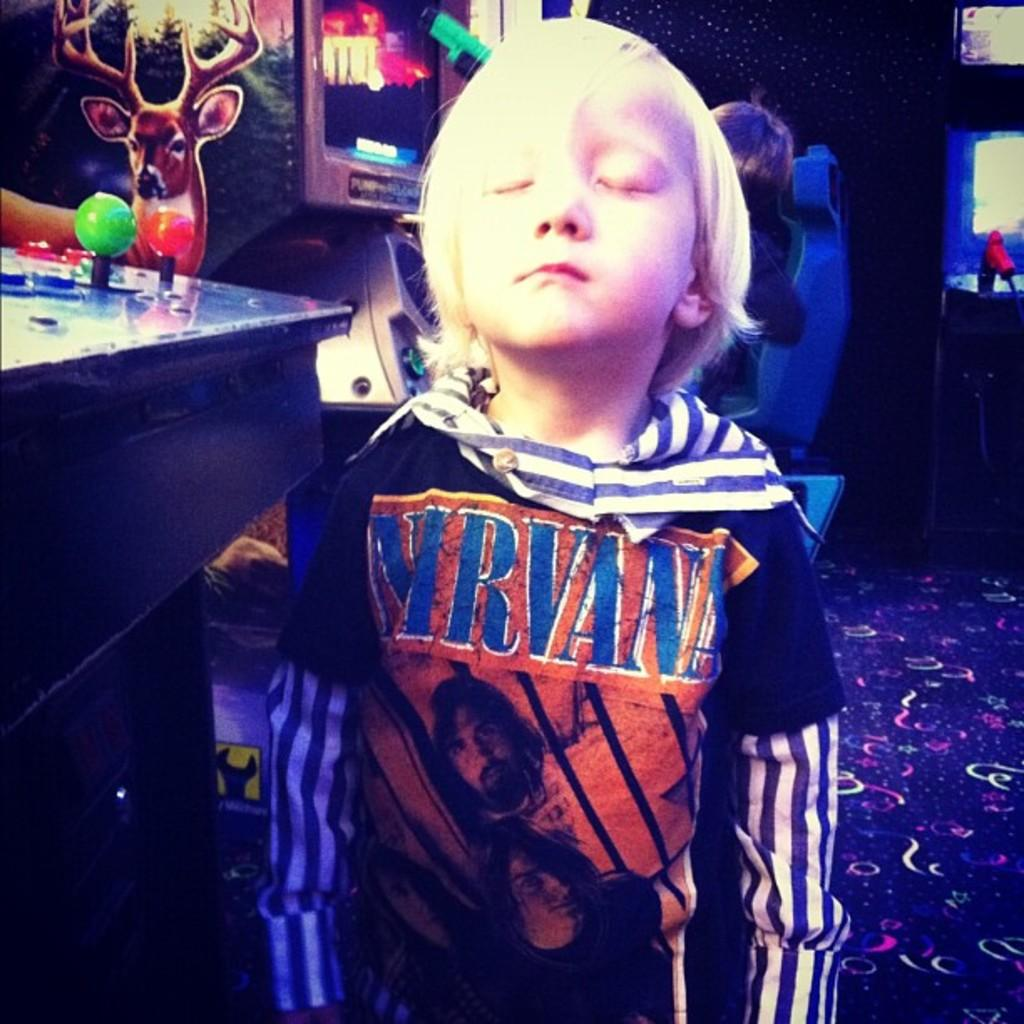<image>
Offer a succinct explanation of the picture presented. In a dark room with black lights on, is a young, blonde boy, with his eyes closed, wearing a Nirvana shirt. 